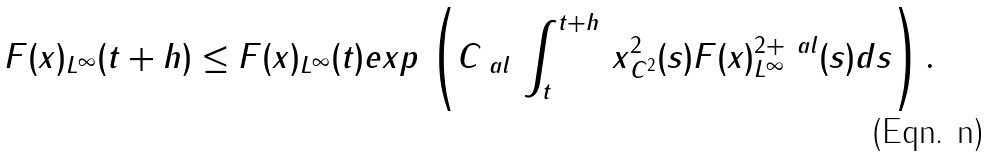Convert formula to latex. <formula><loc_0><loc_0><loc_500><loc_500>\| F ( x ) \| _ { L ^ { \infty } } ( t + h ) & \leq \| F ( x ) \| _ { L ^ { \infty } } ( t ) e x p \, \left ( C _ { \ a l } \, \int _ { t } ^ { t + h } \, \| x \| ^ { 2 } _ { C ^ { 2 } } ( s ) \| F ( x ) \| ^ { 2 + \ a l } _ { L ^ { \infty } } ( s ) d s \right ) .</formula> 